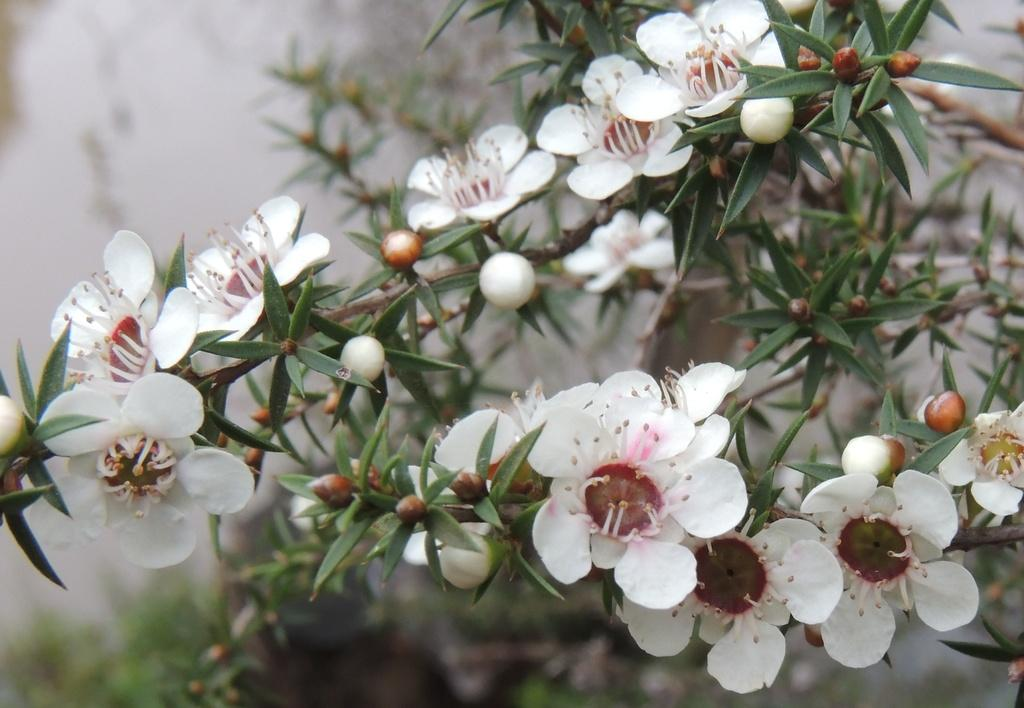What type of flowers are in the foreground of the image? There are white flowers in the foreground of the image. Where are the flowers located? The flowers are on a plant. Can you describe the background of the image? The background of the image is blurred. What type of pipe can be seen in the image? There is no pipe present in the image; it features white flowers on a plant with a blurred background. 